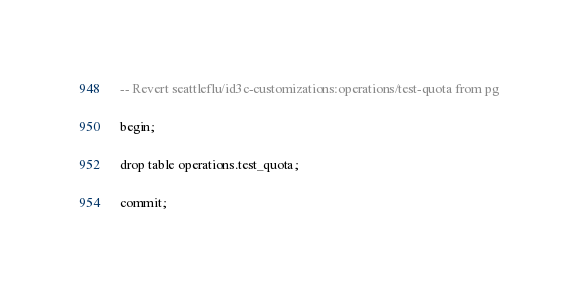Convert code to text. <code><loc_0><loc_0><loc_500><loc_500><_SQL_>-- Revert seattleflu/id3c-customizations:operations/test-quota from pg

begin;

drop table operations.test_quota;

commit;
</code> 